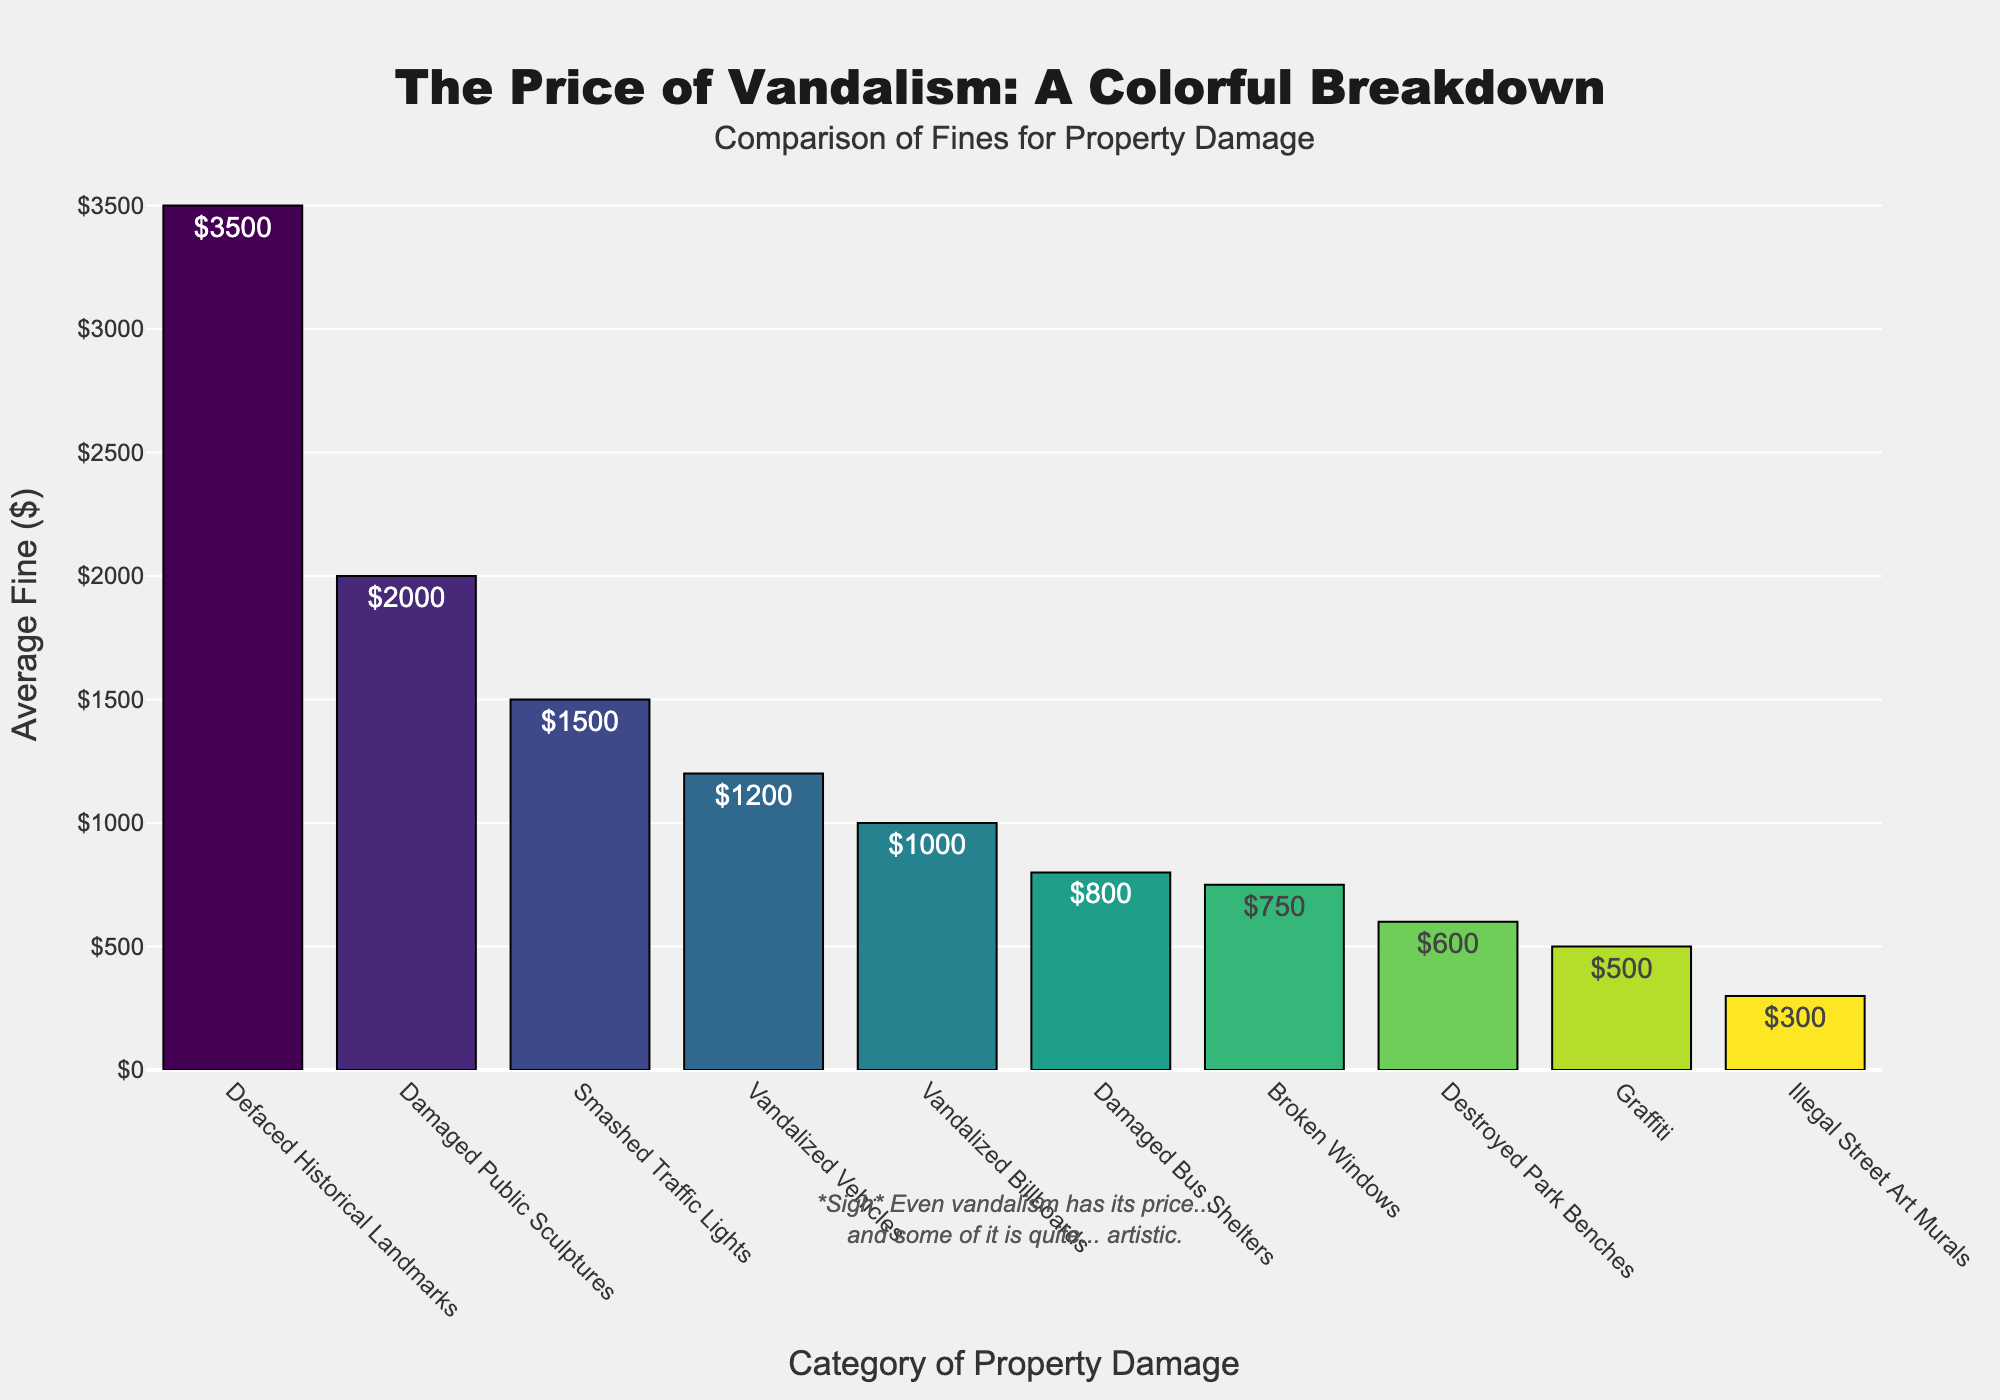Which category has the highest average fine? The category with the highest bar on the chart represents the highest average fine. "Defaced Historical Landmarks" has the highest bar with an average fine of $3500.
Answer: Defaced Historical Landmarks Which category has the lowest average fine? The category with the lowest bar on the chart represents the lowest average fine. "Illegal Street Art Murals" has the lowest bar with an average fine of $300.
Answer: Illegal Street Art Murals How much higher is the fine for "Smashed Traffic Lights" compared to "Vandalized Billboards"? The fine for "Smashed Traffic Lights" is $1500, and the fine for "Vandalized Billboards" is $1000. The difference is $1500 - $1000 = $500.
Answer: $500 What is the combined average fine for "Broken Windows" and "Damaged Bus Shelters"? The average fine for "Broken Windows" is $750, and for "Damaged Bus Shelters" is $800. The combined average fine is $750 + $800 = $1550.
Answer: $1550 How does the average fine for "Graffiti" compare to "Destroyed Park Benches"? The average fine for "Graffiti" is $500 while for "Destroyed Park Benches" it is $600. Since $500 < $600, the fine for "Graffiti" is lower than that for "Destroyed Park Benches".
Answer: Lower Which category has a higher fine: "Damaged Public Sculptures" or "Smashed Traffic Lights"? The average fine for "Damaged Public Sculptures" is $2000, and for "Smashed Traffic Lights" it is $1500. Since $2000 > $1500, "Damaged Public Sculptures" has a higher fine.
Answer: Damaged Public Sculptures What is the range of average fines across all the categories? The range is the difference between the highest average fine and the lowest average fine. The highest average fine is $3500 (Defaced Historical Landmarks) and the lowest average fine is $300 (Illegal Street Art Murals). The range is $3500 - $300 = $3200.
Answer: $3200 Which categories have an average fine of more than $1000? The categories with fines greater than $1000 are: "Damaged Public Sculptures" ($2000), "Defaced Historical Landmarks" ($3500), "Vandalized Vehicles" ($1200), and "Smashed Traffic Lights" ($1500).
Answer: Damaged Public Sculptures, Defaced Historical Landmarks, Vandalized Vehicles, Smashed Traffic Lights 